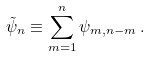<formula> <loc_0><loc_0><loc_500><loc_500>\tilde { \psi } _ { n } \equiv \sum _ { m = 1 } ^ { n } \psi _ { m , n - m } \, .</formula> 